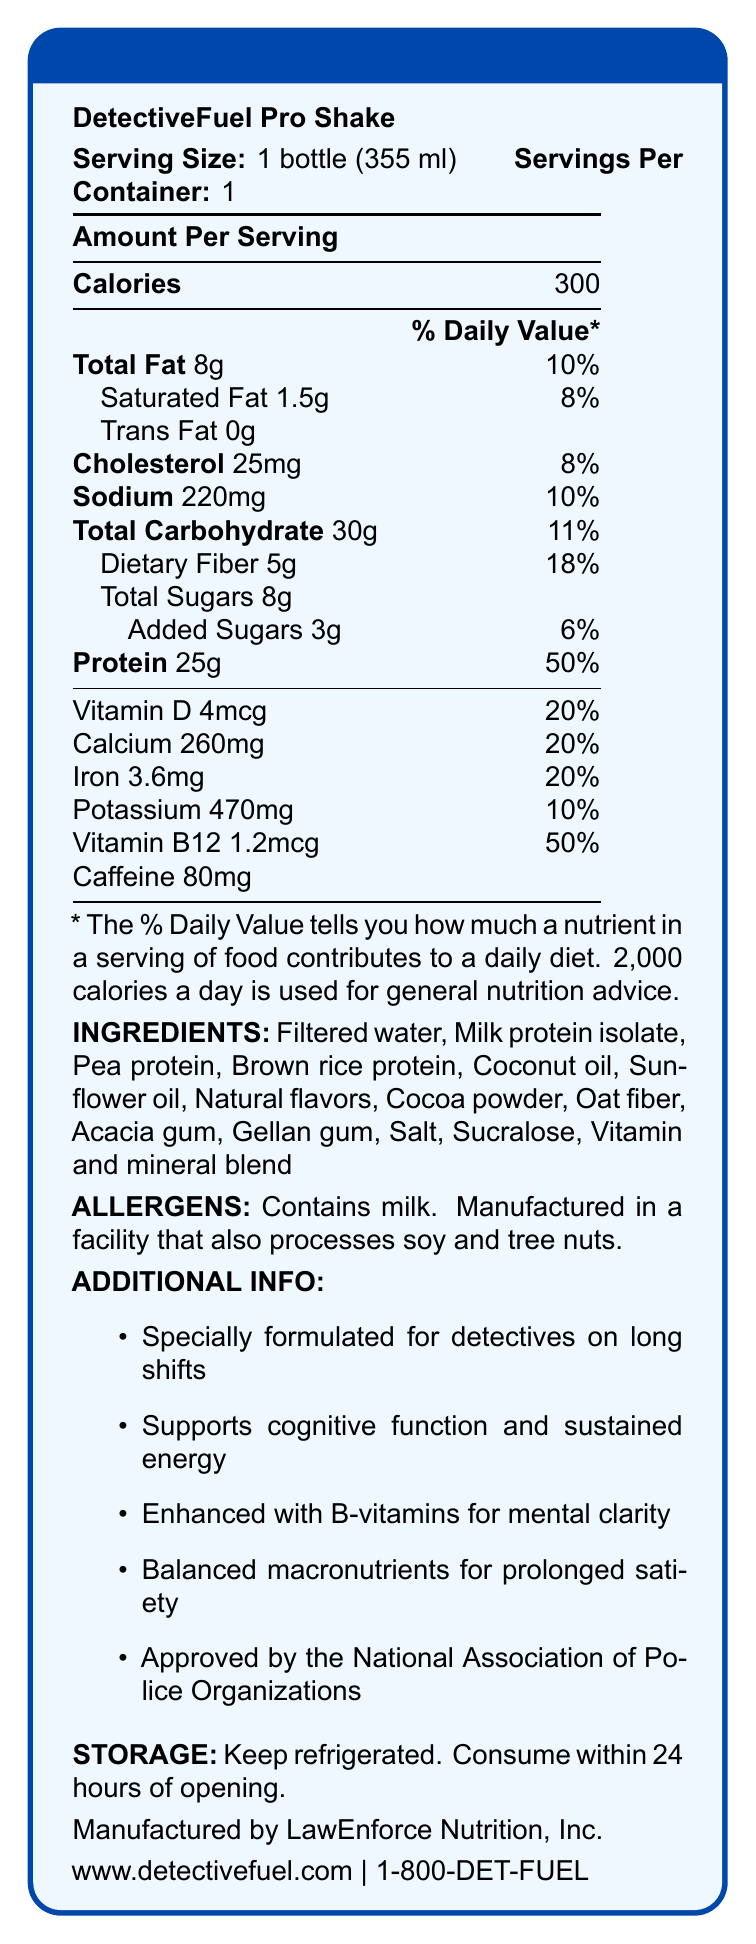What is the serving size of DetectiveFuel Pro Shake? The document states that the serving size is 1 bottle (355 ml).
Answer: 1 bottle (355 ml) What is the amount of protein per serving? The document specifies that each serving contains 25 grams of protein.
Answer: 25g How many calories are in one serving? According to the document, one serving of DetectiveFuel Pro Shake contains 300 calories.
Answer: 300 What percentage of daily value of sodium does one serving provide? The document lists that one serving contains 10% of the daily value for sodium.
Answer: 10% How much added sugars does the shake contain? The document indicates that the DetectiveFuel Pro Shake contains 3 grams of added sugars per serving.
Answer: 3g How many grams of dietary fiber are in each serving? The document specifies that each serving contains 5 grams of dietary fiber.
Answer: 5g Which vitamin in the shake has a daily value percentage of 50%? A. Vitamin D B. Calcium C. Iron D. Vitamin B12 The document states that Vitamin B12's daily value percentage is 50%.
Answer: D. Vitamin B12 Which ingredient listed is a source of fiber in the shake? A. Cocoa powder B. Oat fiber C. Sunflower oil D. Acacia gum The document lists oat fiber as one of the ingredients, which is known to be a source of dietary fiber.
Answer: B. Oat fiber Does the shake contain any trans fat? The document states explicitly that the amount of trans fat is 0 grams.
Answer: No Summarize the document in one sentence. The document outlines all relevant nutritional data, ingredients, special features, and storage info of the DetectiveFuel Pro Shake, aimed at supporting detectives on long shifts.
Answer: The document provides detailed nutritional information about DetectiveFuel Pro Shake, including serving size, calories, nutritional content, ingredients, allergens, additional benefits for detectives, storage instructions, and manufacturer contact details. Who manufactures the DetectiveFuel Pro Shake? The document specifies that LawEnforce Nutrition, Inc. is the manufacturer of the drink.
Answer: LawEnforce Nutrition, Inc. What website can be visited for more information? The document provides the URL www.detectivefuel.com for more information.
Answer: www.detectivefuel.com How much caffeine is in one serving of the shake? According to the document, one serving of the protein shake contains 80mg of caffeine.
Answer: 80mg Based on the information in the document, can you determine the exact price of the DetectiveFuel Pro Shake? The document does not provide any information regarding the price of the product.
Answer: Cannot be determined Is the DetectiveFuel Pro Shake suitable for people with a tree nut allergy? The document notes that it is manufactured in a facility that also processes tree nuts, which may not be suitable for individuals with a tree nut allergy.
Answer: No What percentage of daily value of iron does one serving provide? The document lists that one serving provides 20% of the daily value for iron.
Answer: 20% Which of these is NOT an ingredient in the DetectiveFuel Pro Shake? A. Milk protein isolate B. Pea protein C. Soy protein D. Brown rice protein The document lists the ingredients and does not include soy protein among them.
Answer: C. Soy protein Does the shake support cognitive function and sustained energy? The document specifically mentions that the shake supports cognitive function and sustained energy.
Answer: Yes What storage instructions are provided for the DetectiveFuel Pro Shake? The document advises to keep the shake refrigerated and consume it within 24 hours of opening.
Answer: Keep refrigerated. Consume within 24 hours of opening. What organization has approved the DetectiveFuel Pro Shake? The document states that the shake is approved by the National Association of Police Organizations.
Answer: National Association of Police Organizations 